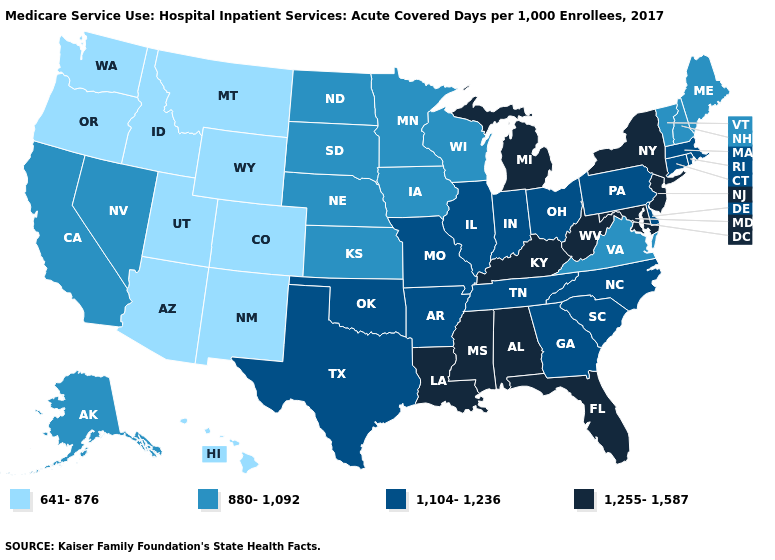Which states hav the highest value in the Northeast?
Concise answer only. New Jersey, New York. What is the value of Kansas?
Be succinct. 880-1,092. Name the states that have a value in the range 1,104-1,236?
Write a very short answer. Arkansas, Connecticut, Delaware, Georgia, Illinois, Indiana, Massachusetts, Missouri, North Carolina, Ohio, Oklahoma, Pennsylvania, Rhode Island, South Carolina, Tennessee, Texas. Does the map have missing data?
Keep it brief. No. Name the states that have a value in the range 880-1,092?
Concise answer only. Alaska, California, Iowa, Kansas, Maine, Minnesota, Nebraska, Nevada, New Hampshire, North Dakota, South Dakota, Vermont, Virginia, Wisconsin. Among the states that border North Carolina , which have the highest value?
Quick response, please. Georgia, South Carolina, Tennessee. Name the states that have a value in the range 1,255-1,587?
Quick response, please. Alabama, Florida, Kentucky, Louisiana, Maryland, Michigan, Mississippi, New Jersey, New York, West Virginia. Does Wisconsin have a higher value than Oregon?
Be succinct. Yes. Which states have the lowest value in the MidWest?
Quick response, please. Iowa, Kansas, Minnesota, Nebraska, North Dakota, South Dakota, Wisconsin. What is the lowest value in the USA?
Concise answer only. 641-876. What is the value of Arkansas?
Short answer required. 1,104-1,236. What is the highest value in the USA?
Answer briefly. 1,255-1,587. Does South Dakota have the lowest value in the MidWest?
Write a very short answer. Yes. Does the first symbol in the legend represent the smallest category?
Keep it brief. Yes. What is the lowest value in the West?
Concise answer only. 641-876. 